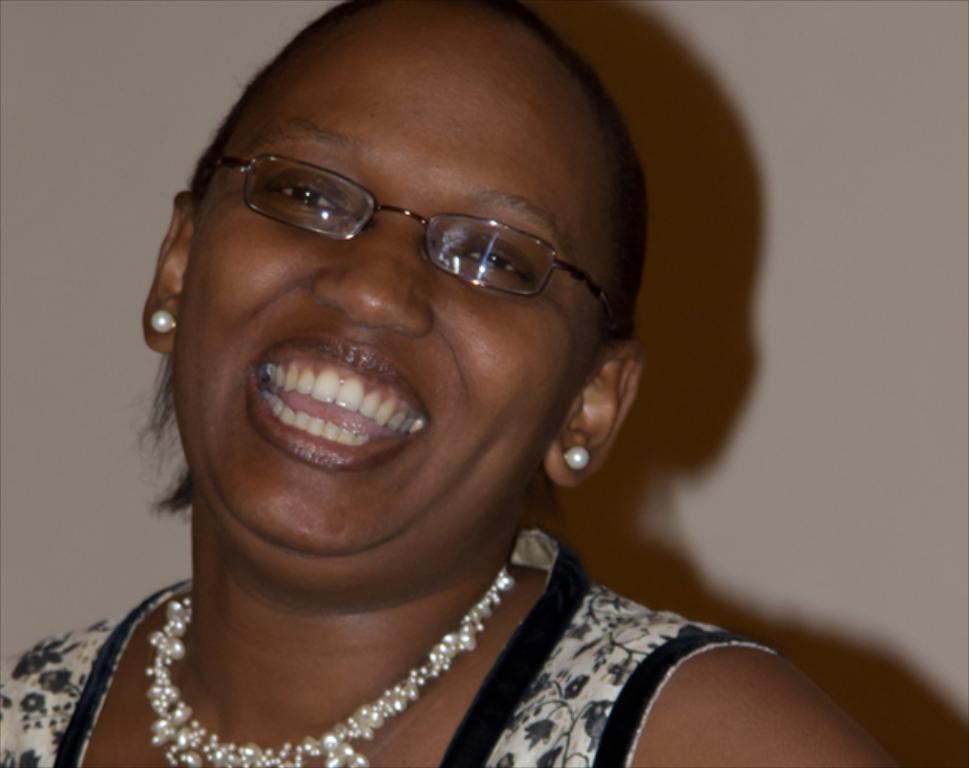How would you summarize this image in a sentence or two? In this image, we can see a woman is smiling and wearing glasses. Background there is a wall. 